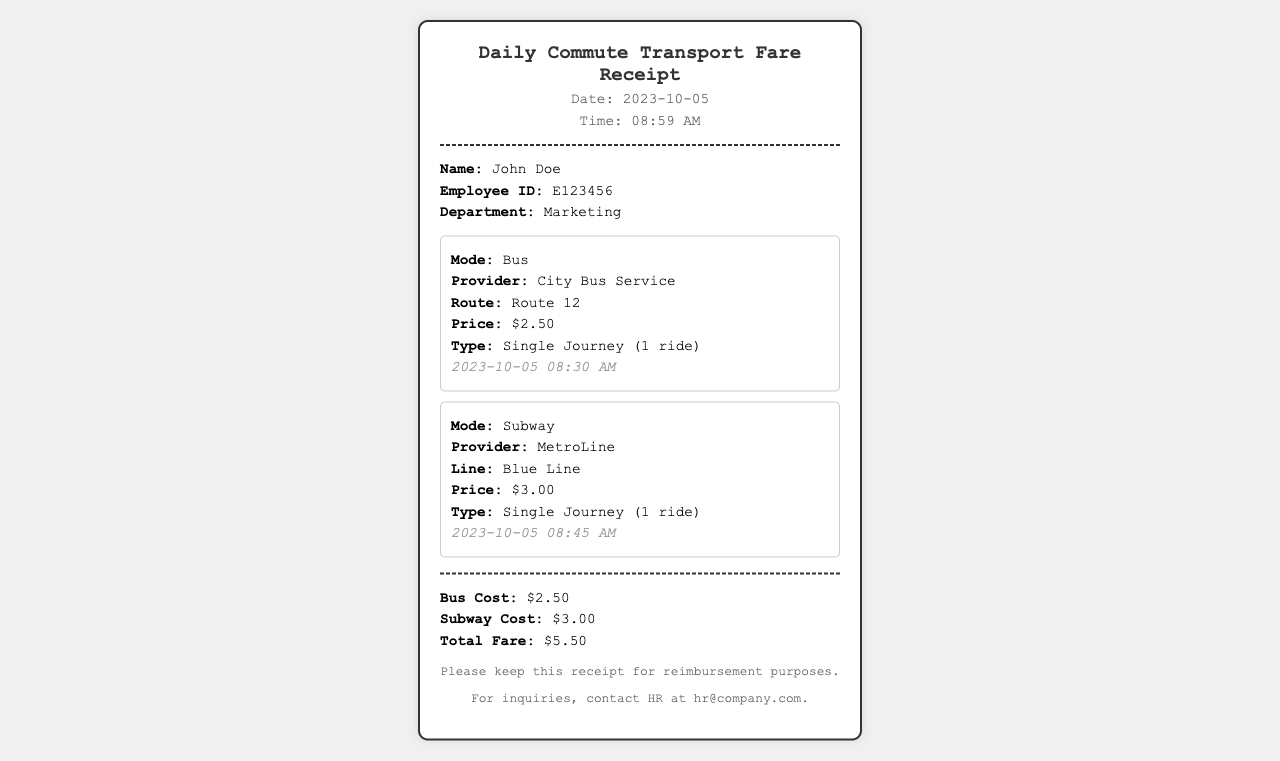What is the date of the receipt? The receipt shows the date as "2023-10-05."
Answer: 2023-10-05 What is the name of the employee? The employee's name is stated as "John Doe."
Answer: John Doe What is the total fare? The total fare is provided at the end of the receipt as "$5.50."
Answer: $5.50 Which bus provider is mentioned? The provider for the bus ride is listed as "City Bus Service."
Answer: City Bus Service What time did the subway ride occur? The timestamp for the subway ride is noted as "2023-10-05 08:45 AM."
Answer: 08:45 AM How much does a single subway ride cost? The document specifies the cost of a single subway ride as "$3.00."
Answer: $3.00 What mode of transport was used first? The first mode of transport mentioned is "Bus."
Answer: Bus How many rides were taken for the subway? The receipt states that the subway ride type is "Single Journey (1 ride)."
Answer: 1 ride What department does the employee belong to? The document states that the department is "Marketing."
Answer: Marketing 